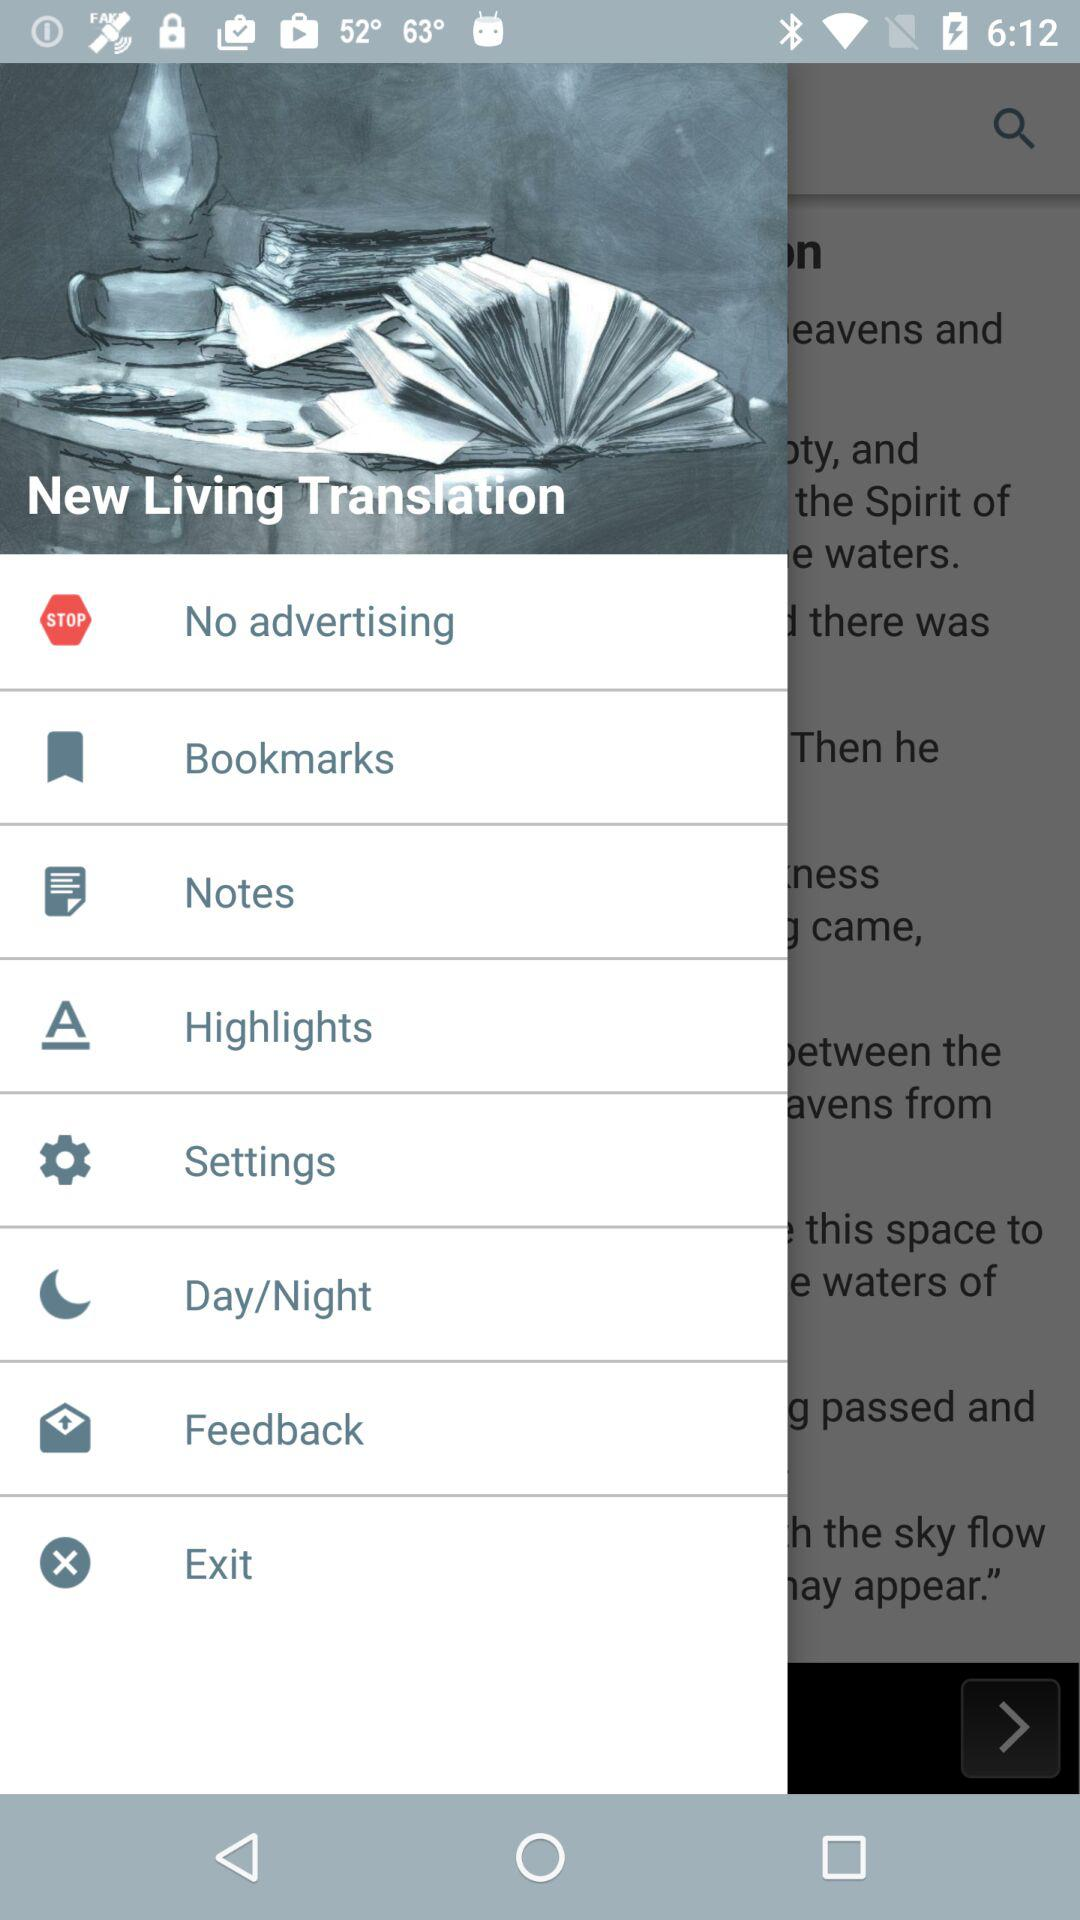What is the application name? The application name is "New Living Translation". 